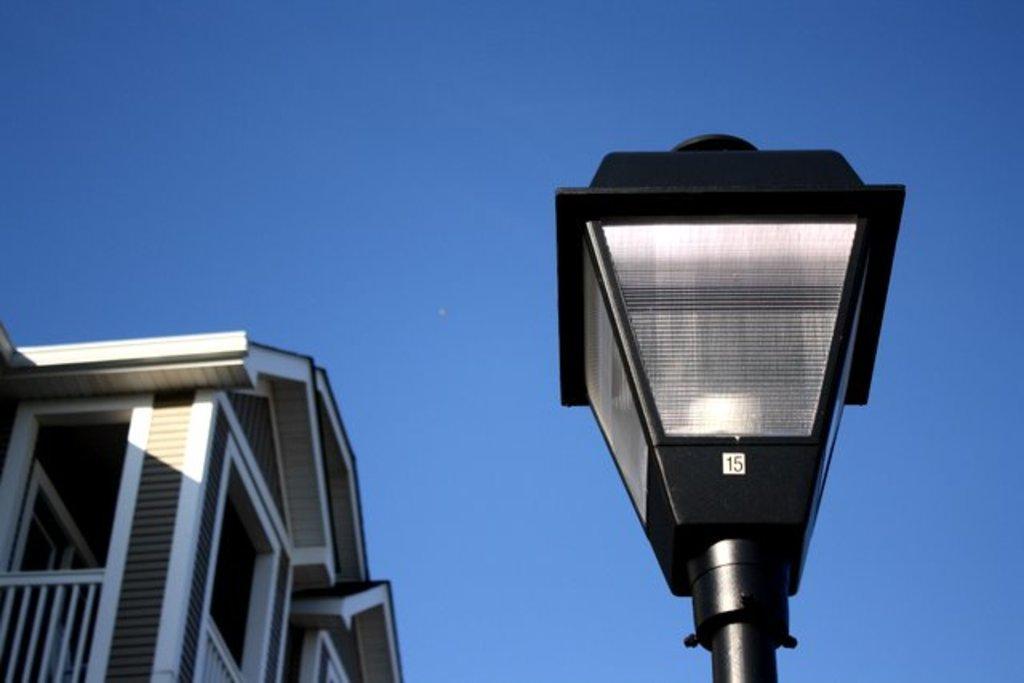Please provide a concise description of this image. In the picture I can see a decorative light pole on the right side. I can see the building on the left side. I can see the blue sky. 